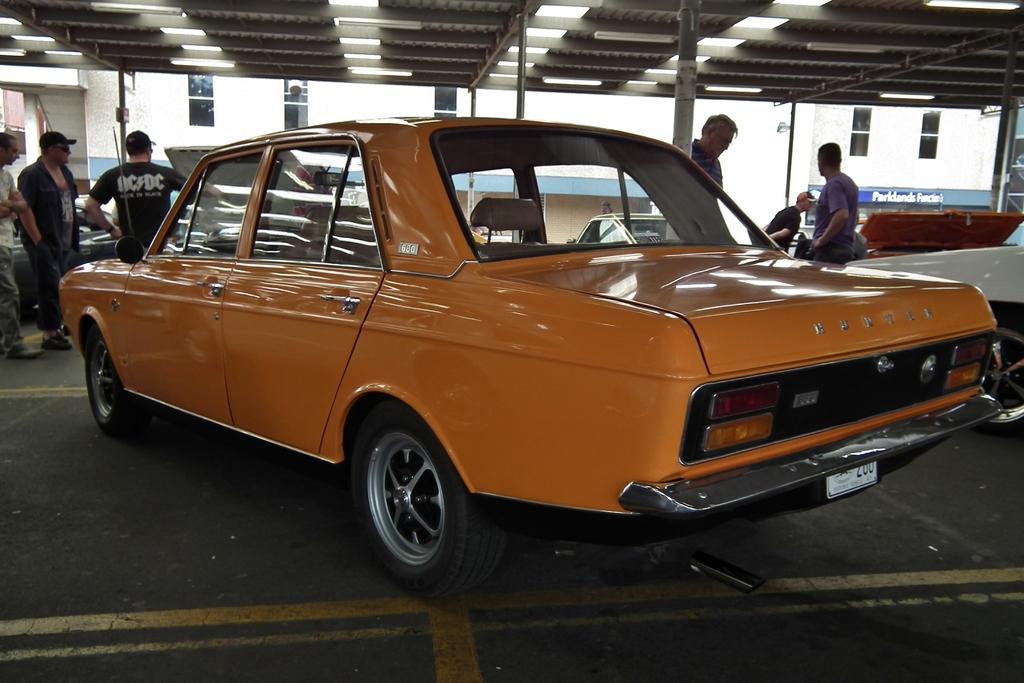Describe this image in one or two sentences. In this image we can see a few vehicles and people, there are some poles and windows, at the top of the roof, we can see some lights, in the background we can see a white color building. 